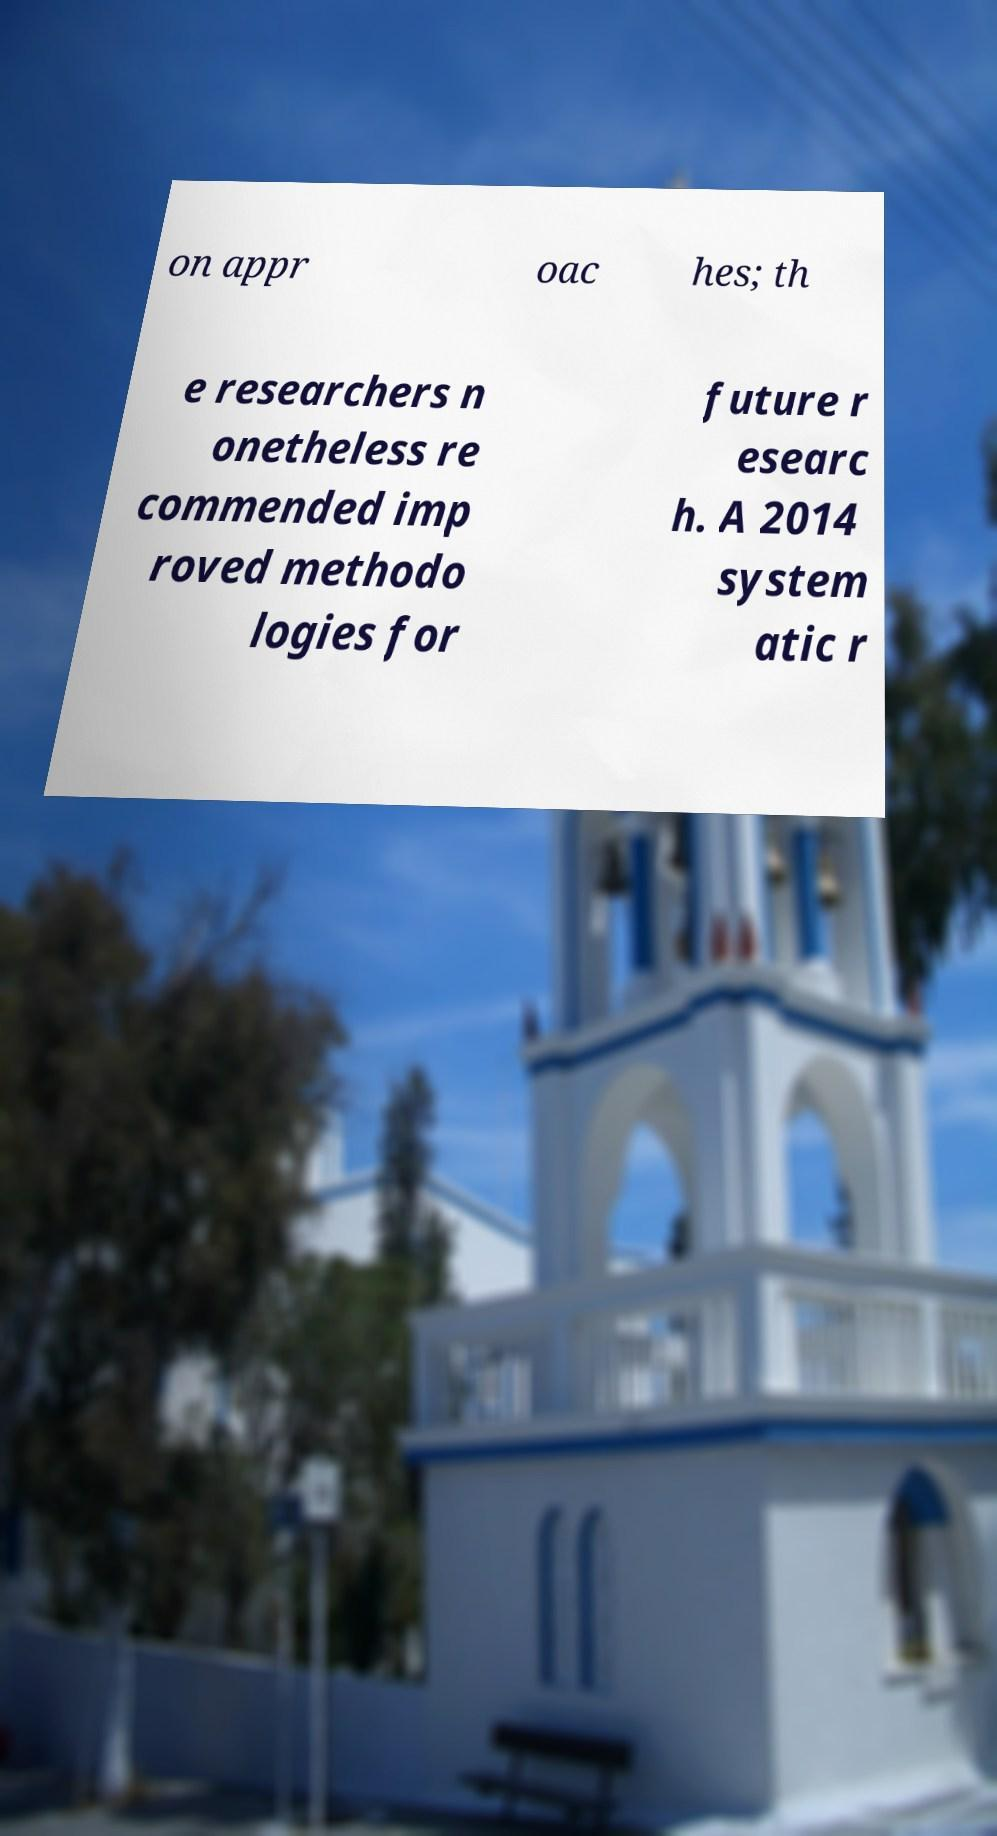Could you assist in decoding the text presented in this image and type it out clearly? on appr oac hes; th e researchers n onetheless re commended imp roved methodo logies for future r esearc h. A 2014 system atic r 